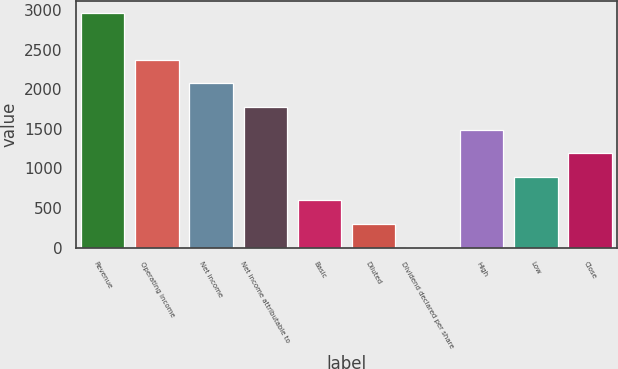Convert chart to OTSL. <chart><loc_0><loc_0><loc_500><loc_500><bar_chart><fcel>Revenue<fcel>Operating income<fcel>Net income<fcel>Net income attributable to<fcel>Basic<fcel>Diluted<fcel>Dividend declared per share<fcel>High<fcel>Low<fcel>Close<nl><fcel>2965<fcel>2372.5<fcel>2076.25<fcel>1780<fcel>595<fcel>298.75<fcel>2.5<fcel>1483.75<fcel>891.25<fcel>1187.5<nl></chart> 